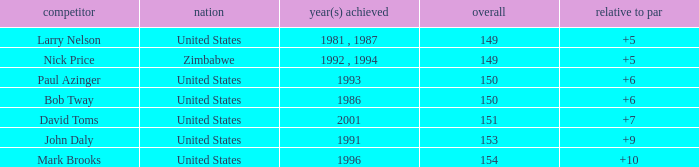How many to pars were won in 1993? 1.0. 